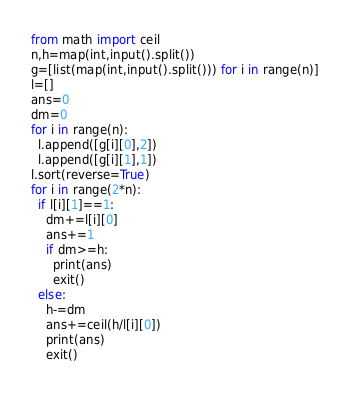Convert code to text. <code><loc_0><loc_0><loc_500><loc_500><_Python_>from math import ceil
n,h=map(int,input().split())
g=[list(map(int,input().split())) for i in range(n)]
l=[]
ans=0
dm=0
for i in range(n):
  l.append([g[i][0],2])
  l.append([g[i][1],1])
l.sort(reverse=True)
for i in range(2*n):
  if l[i][1]==1:
    dm+=l[i][0]
    ans+=1
    if dm>=h:
      print(ans)
      exit()
  else:
    h-=dm
    ans+=ceil(h/l[i][0])
    print(ans)
    exit()
    </code> 